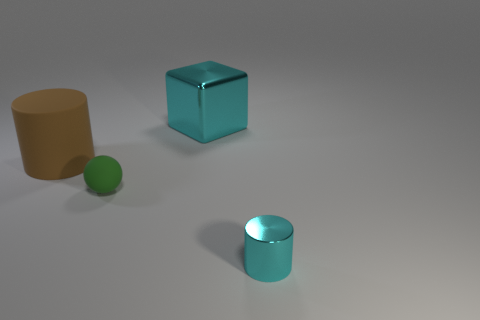Is there any other thing that is the same shape as the green rubber object?
Provide a succinct answer. No. The cyan object that is the same shape as the large brown object is what size?
Your answer should be compact. Small. Is the shape of the small cyan metallic thing the same as the brown matte thing?
Give a very brief answer. Yes. Are there fewer large cubes that are to the left of the cyan shiny cube than big cubes behind the ball?
Provide a short and direct response. Yes. There is a brown cylinder; what number of objects are on the right side of it?
Your response must be concise. 3. There is a brown object that is behind the tiny cylinder; is it the same shape as the cyan metallic thing in front of the large brown rubber thing?
Offer a terse response. Yes. How many other objects are the same color as the large metal cube?
Your answer should be compact. 1. What material is the cyan object behind the cyan metallic object in front of the metal object that is behind the small green object?
Ensure brevity in your answer.  Metal. What material is the cyan object on the left side of the thing in front of the green rubber sphere?
Your answer should be very brief. Metal. Are there fewer green matte spheres on the right side of the small cyan metallic thing than tiny green objects?
Your answer should be very brief. Yes. 